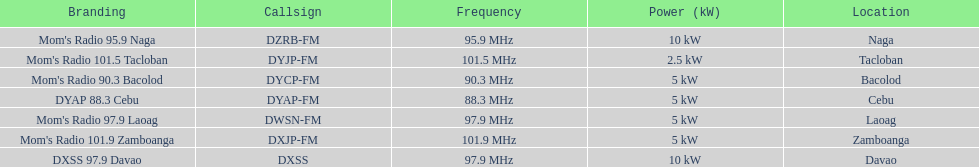How many kw was the radio in davao? 10 kW. 